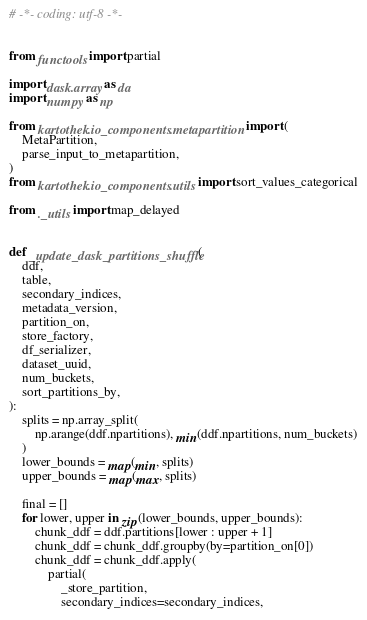<code> <loc_0><loc_0><loc_500><loc_500><_Python_># -*- coding: utf-8 -*-


from functools import partial

import dask.array as da
import numpy as np

from kartothek.io_components.metapartition import (
    MetaPartition,
    parse_input_to_metapartition,
)
from kartothek.io_components.utils import sort_values_categorical

from ._utils import map_delayed


def _update_dask_partitions_shuffle(
    ddf,
    table,
    secondary_indices,
    metadata_version,
    partition_on,
    store_factory,
    df_serializer,
    dataset_uuid,
    num_buckets,
    sort_partitions_by,
):
    splits = np.array_split(
        np.arange(ddf.npartitions), min(ddf.npartitions, num_buckets)
    )
    lower_bounds = map(min, splits)
    upper_bounds = map(max, splits)

    final = []
    for lower, upper in zip(lower_bounds, upper_bounds):
        chunk_ddf = ddf.partitions[lower : upper + 1]
        chunk_ddf = chunk_ddf.groupby(by=partition_on[0])
        chunk_ddf = chunk_ddf.apply(
            partial(
                _store_partition,
                secondary_indices=secondary_indices,</code> 